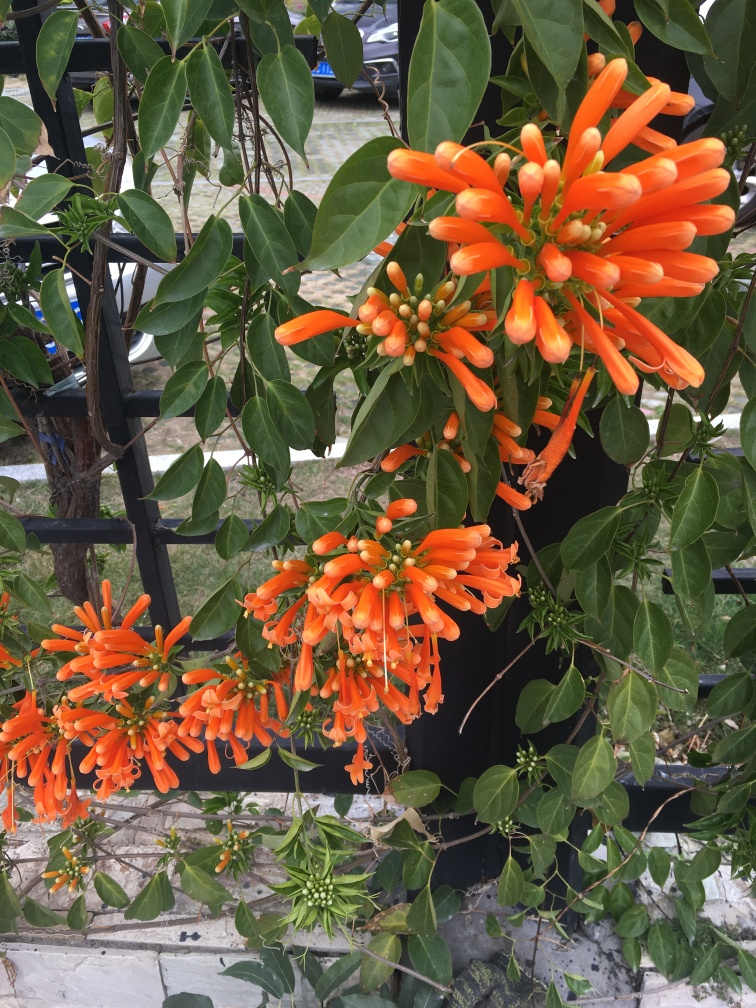How is the lighting in the image? The lighting in the image is well balanced, providing sufficient illumination without overexposing any parts of the scene or creating harsh shadows. The natural light accentuates the vibrant colors of the orange flowers, creating a lively and inviting composition. 